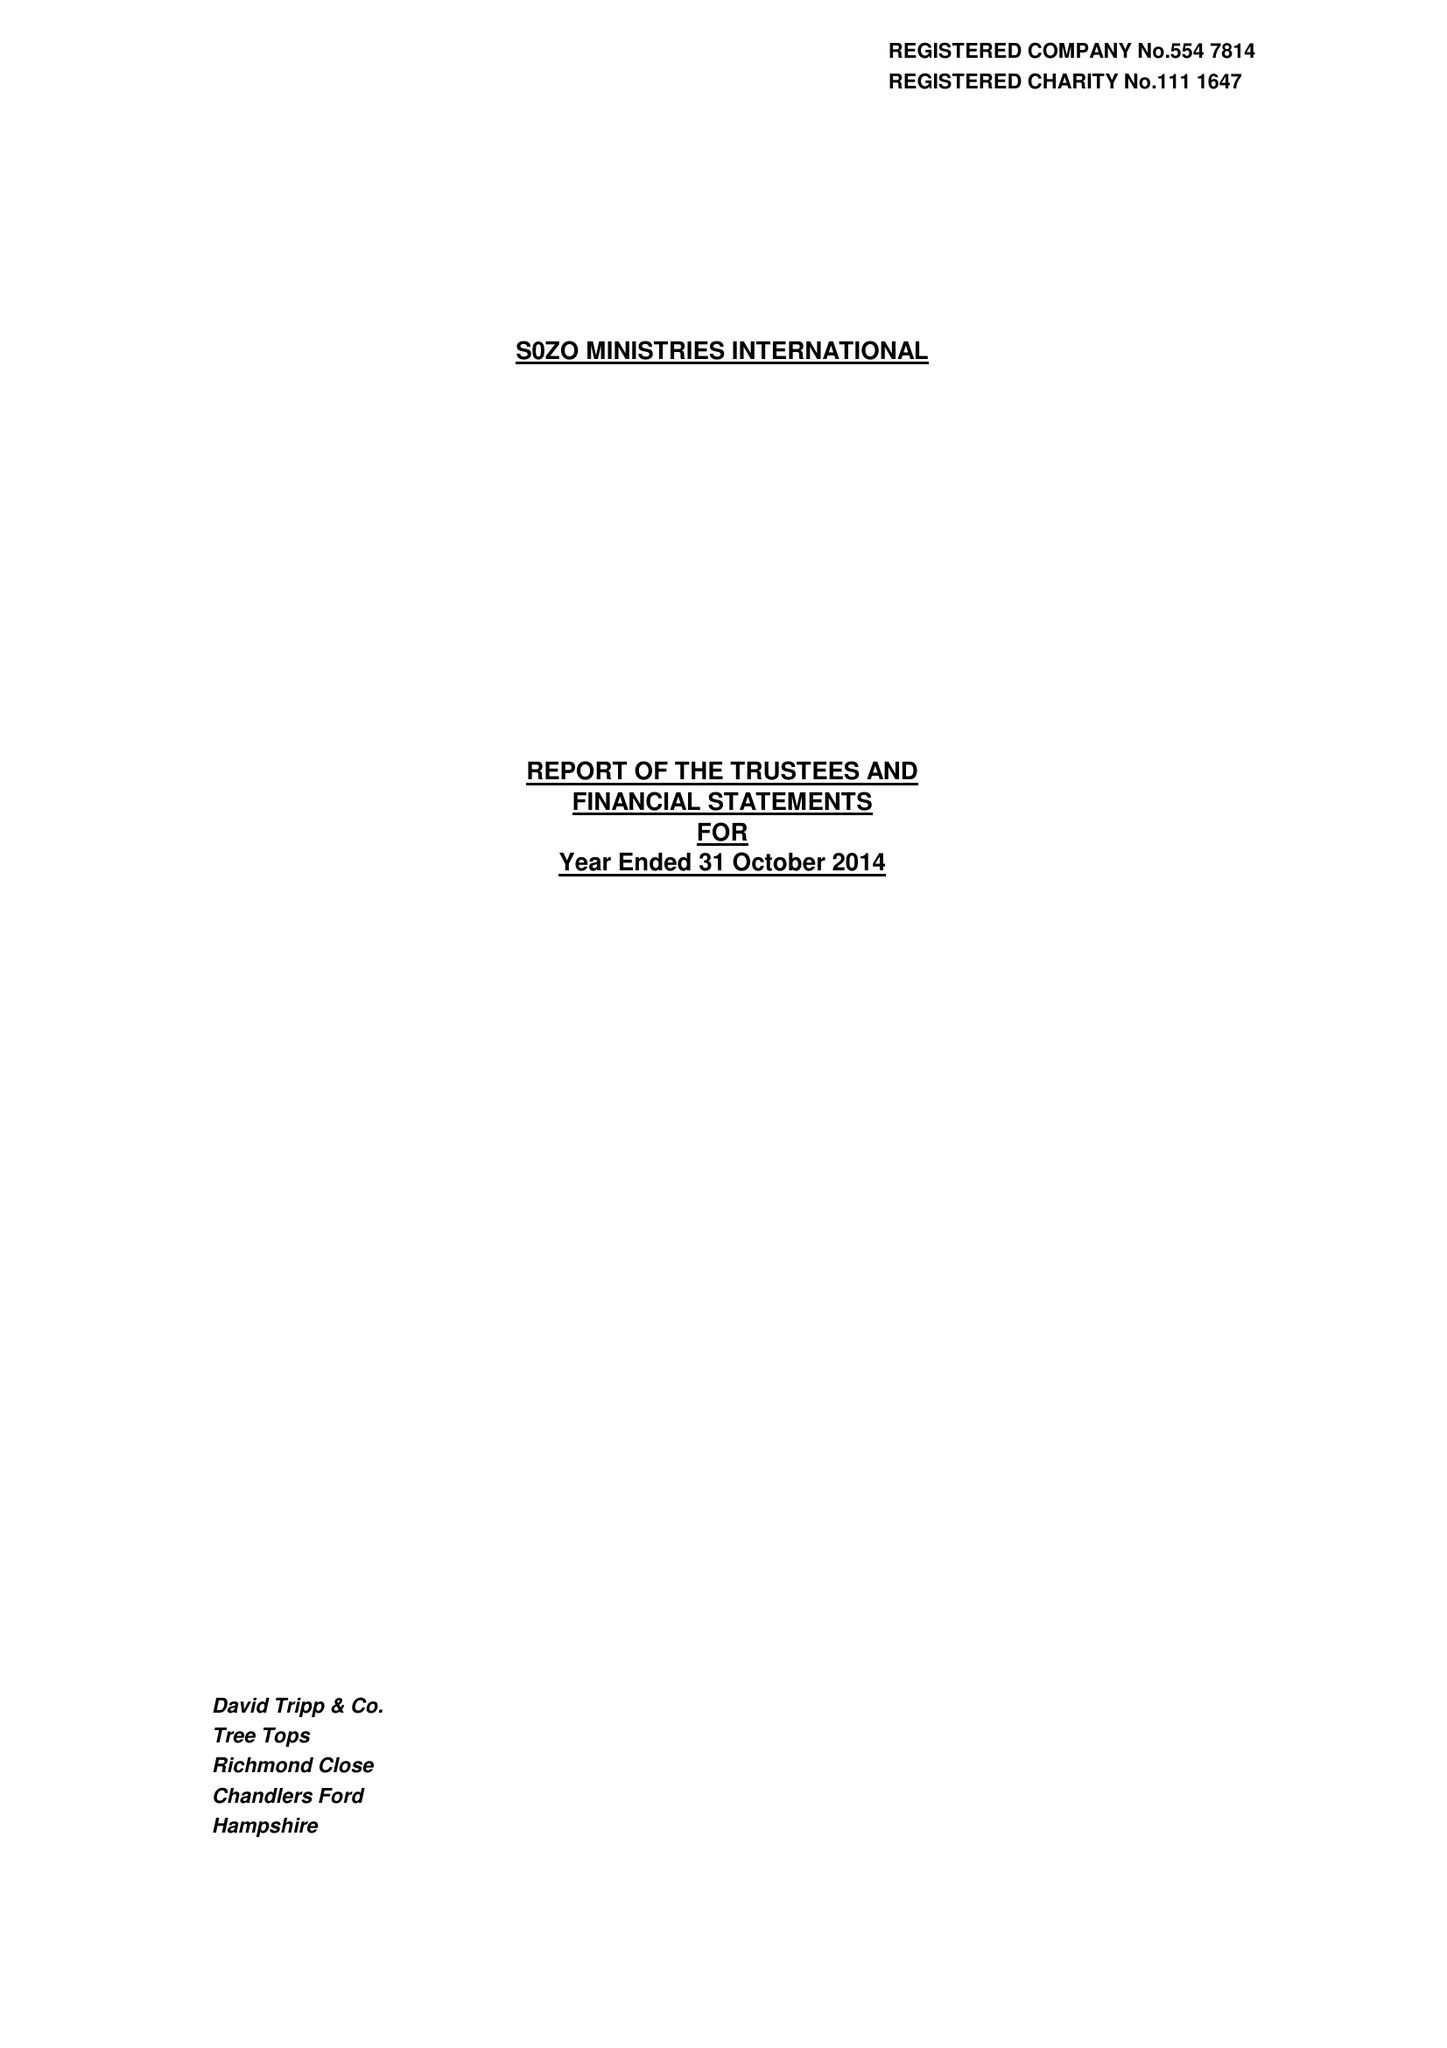What is the value for the charity_number?
Answer the question using a single word or phrase. 1111647 